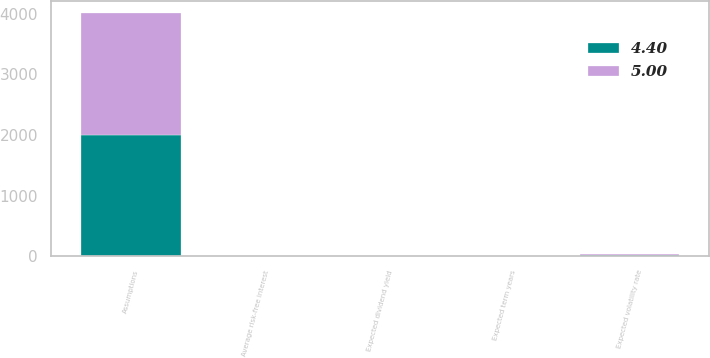Convert chart. <chart><loc_0><loc_0><loc_500><loc_500><stacked_bar_chart><ecel><fcel>Assumptions<fcel>Expected volatility rate<fcel>Expected dividend yield<fcel>Average risk-free interest<fcel>Expected term years<nl><fcel>4.4<fcel>2007<fcel>20.8<fcel>2.92<fcel>4.24<fcel>4.4<nl><fcel>5<fcel>2005<fcel>22.9<fcel>3.29<fcel>4.48<fcel>5<nl></chart> 